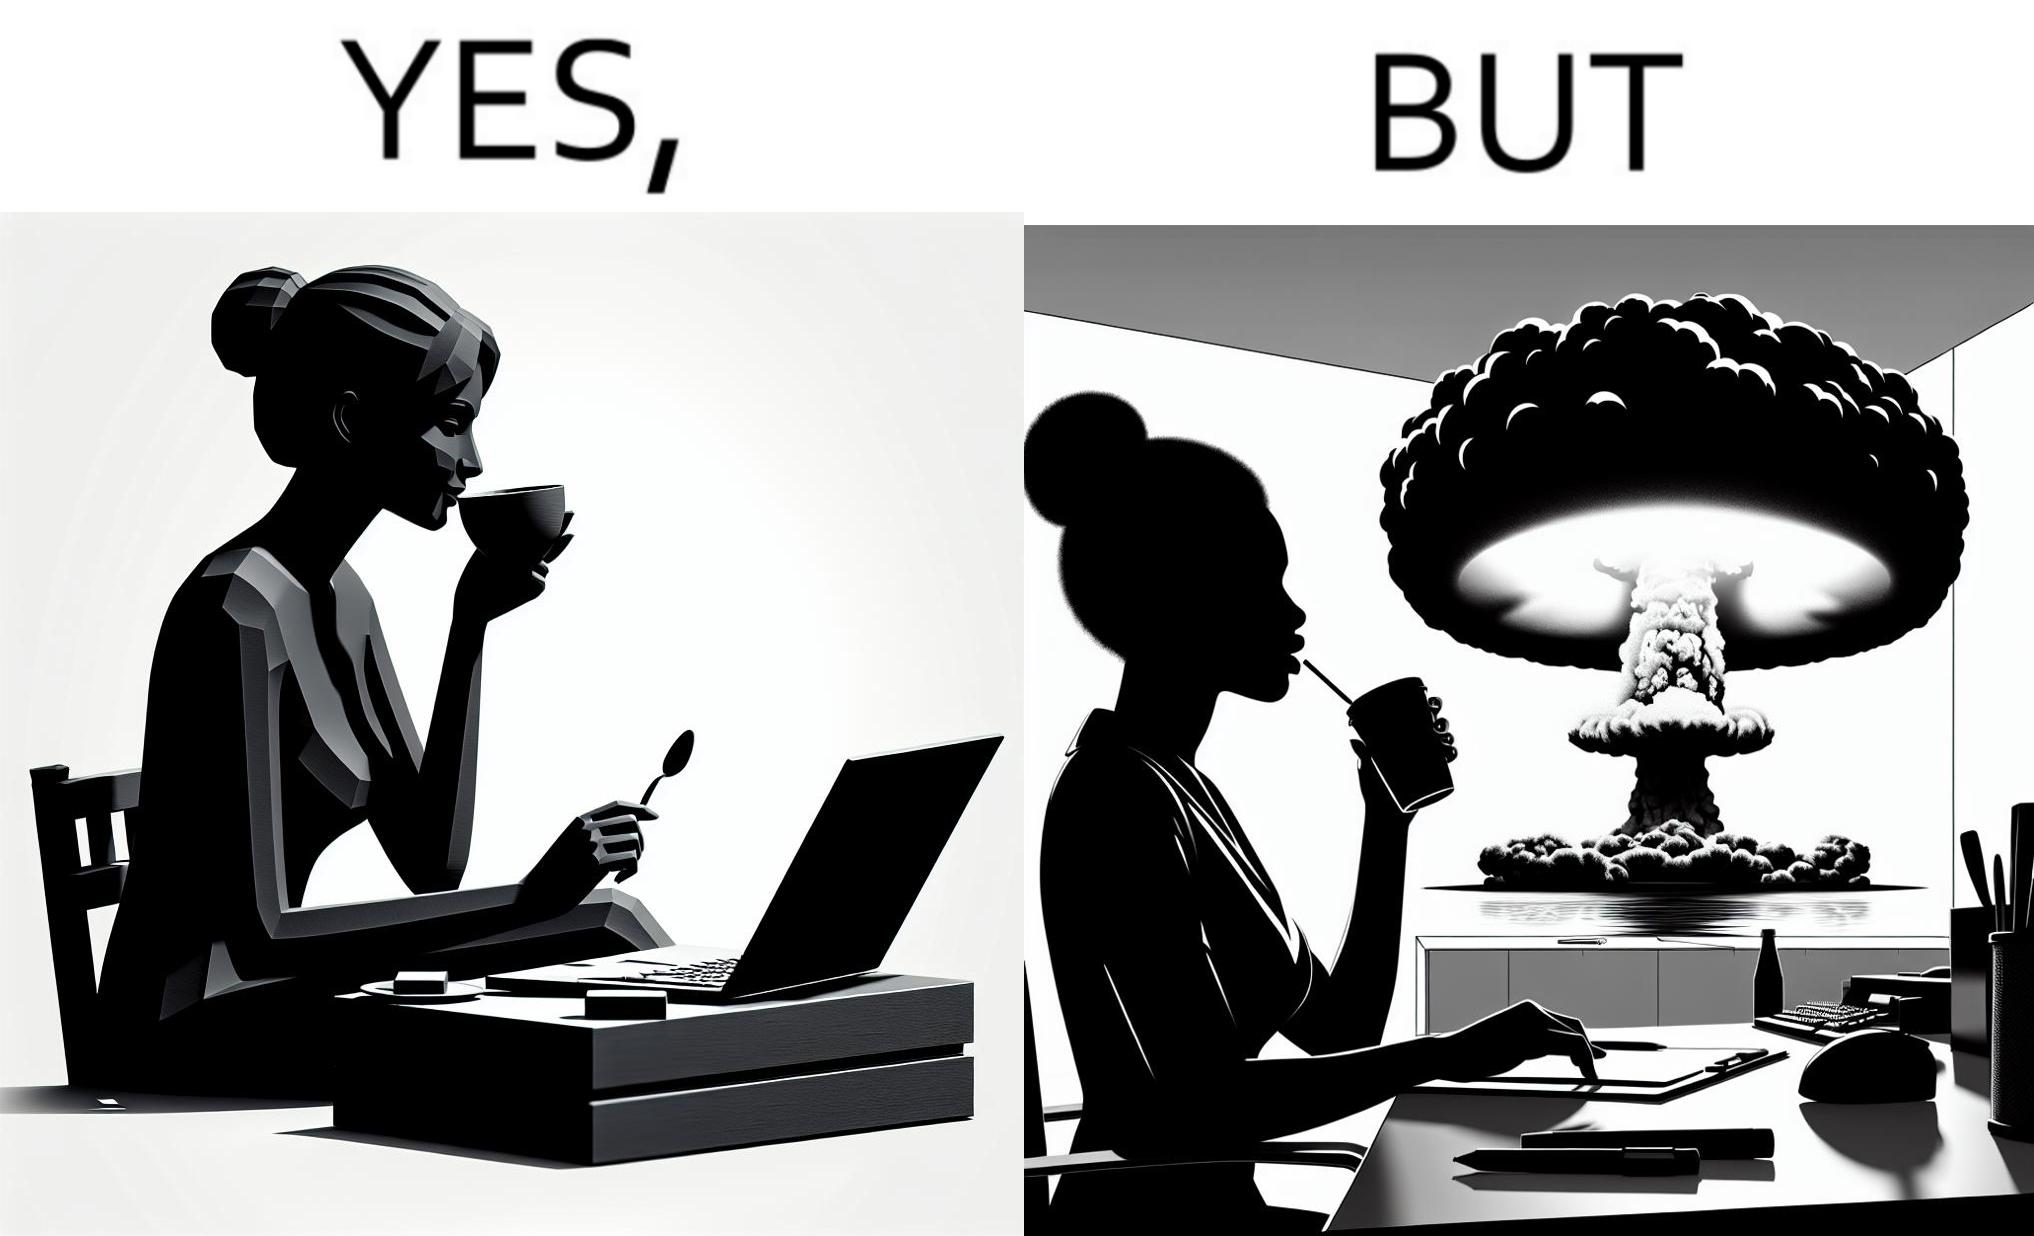Does this image contain satire or humor? Yes, this image is satirical. 